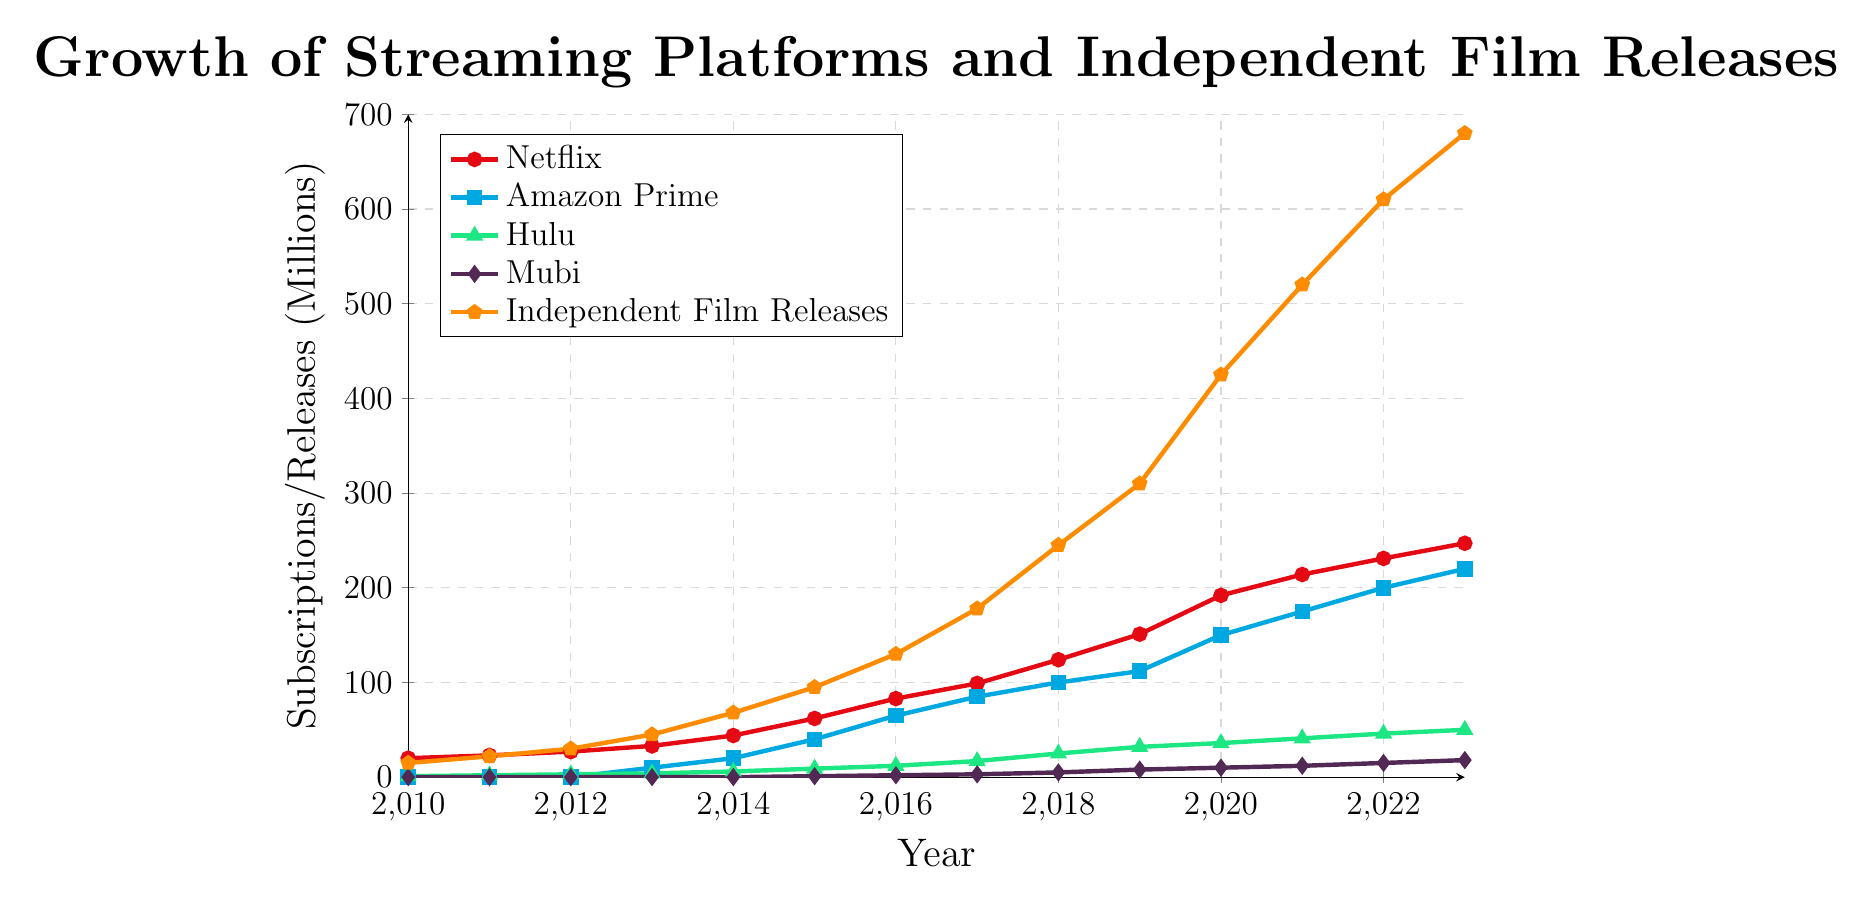What trend is observed in the number of Netflix subscriptions from 2010 to 2023? Looking at the red line representing Netflix, we see a continuous upward trend starting from 20 million subscriptions in 2010 and reaching 247 million subscriptions by 2023.
Answer: Continuous upward trend In what year did Amazon Prime show a significant increase from zero subscriptions? The blue line representing Amazon Prime shows that significant subscriptions began in 2013 when subscriptions jumped to 10 million.
Answer: 2013 Which platform shows the least growth from 2010 to 2023? The purple line representing Mubi shows the least growth, starting from zero subscriptions in 2010 and reaching only 18 million subscriptions by 2023.
Answer: Mubi Compare Hulu's subscription growth to Mubi's from 2015 to 2023. In 2015, Hulu's subscriptions were 9 million and grew to 50 million by 2023. Mubi, on the other hand, had 1 million subscriptions in 2015 and grew to 18 million by 2023. Thus, Hulu had a faster and larger growth in subscriptions compared to Mubi during this period.
Answer: Hulu had faster growth What is the relationship between the number of Independent Film Releases and Netflix subscriptions over time? Observing both the orange line for Independent Film Releases and the red line for Netflix, both show a similar upward trend, suggesting a potential relationship where an increase in Netflix's subscriptions may be associated with an increase in independent film releases on streaming platforms.
Answer: Both show an upward trend How many more independent films were released on streaming platforms in 2023 compared to 2015? In 2015, there were 95 independent film releases, and in 2023, there were 680. The difference is 680 - 95 = 585 more films released in 2023 compared to 2015.
Answer: 585 more films Which platform had the highest number of subscriptions in 2020? In 2020, the red line (Netflix) reaches 192 million, which is higher than Amazon Prime (150 million), Hulu (36 million), and Mubi (10 million).
Answer: Netflix What is the combined total of subscriptions for Hulu, Amazon Prime, and Mubi in 2023? Hulu has 50 million, Amazon Prime has 220 million, and Mubi has 18 million in 2023. Summing these values: 50 + 220 + 18 = 288 million total subscriptions.
Answer: 288 million Between which consecutive years did the number of Independent Film Releases see the largest increase? By examining the steepness of the orange line, the most significant rise occurs between 2019 and 2020, where releases jumped from 310 to 425. This is an increase of 425 - 310 = 115.
Answer: Between 2019 and 2020 Does any streaming platform show declining subscriptions at any point in time? No trend lines for Netflix, Amazon Prime, Hulu, or Mubi show any decline over the years; all platforms display continuous growth.
Answer: No 